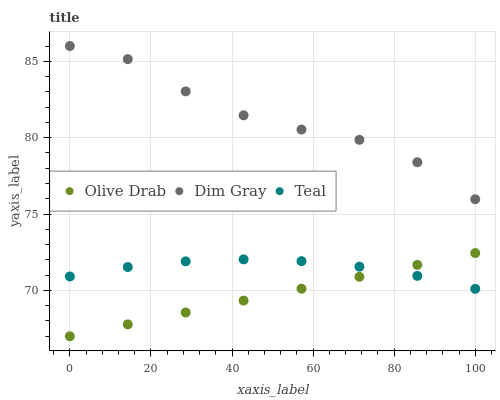Does Olive Drab have the minimum area under the curve?
Answer yes or no. Yes. Does Dim Gray have the maximum area under the curve?
Answer yes or no. Yes. Does Teal have the minimum area under the curve?
Answer yes or no. No. Does Teal have the maximum area under the curve?
Answer yes or no. No. Is Olive Drab the smoothest?
Answer yes or no. Yes. Is Dim Gray the roughest?
Answer yes or no. Yes. Is Teal the smoothest?
Answer yes or no. No. Is Teal the roughest?
Answer yes or no. No. Does Olive Drab have the lowest value?
Answer yes or no. Yes. Does Teal have the lowest value?
Answer yes or no. No. Does Dim Gray have the highest value?
Answer yes or no. Yes. Does Olive Drab have the highest value?
Answer yes or no. No. Is Teal less than Dim Gray?
Answer yes or no. Yes. Is Dim Gray greater than Olive Drab?
Answer yes or no. Yes. Does Teal intersect Olive Drab?
Answer yes or no. Yes. Is Teal less than Olive Drab?
Answer yes or no. No. Is Teal greater than Olive Drab?
Answer yes or no. No. Does Teal intersect Dim Gray?
Answer yes or no. No. 